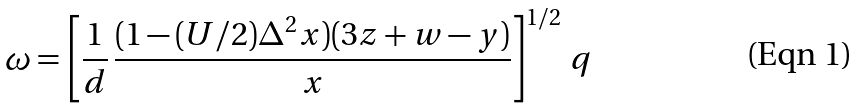<formula> <loc_0><loc_0><loc_500><loc_500>\omega = \left [ \frac { 1 } { d } \, \frac { ( 1 - ( U / 2 ) \Delta ^ { 2 } x ) ( 3 z + w - y ) } { x } \right ] ^ { 1 / 2 } \, q</formula> 